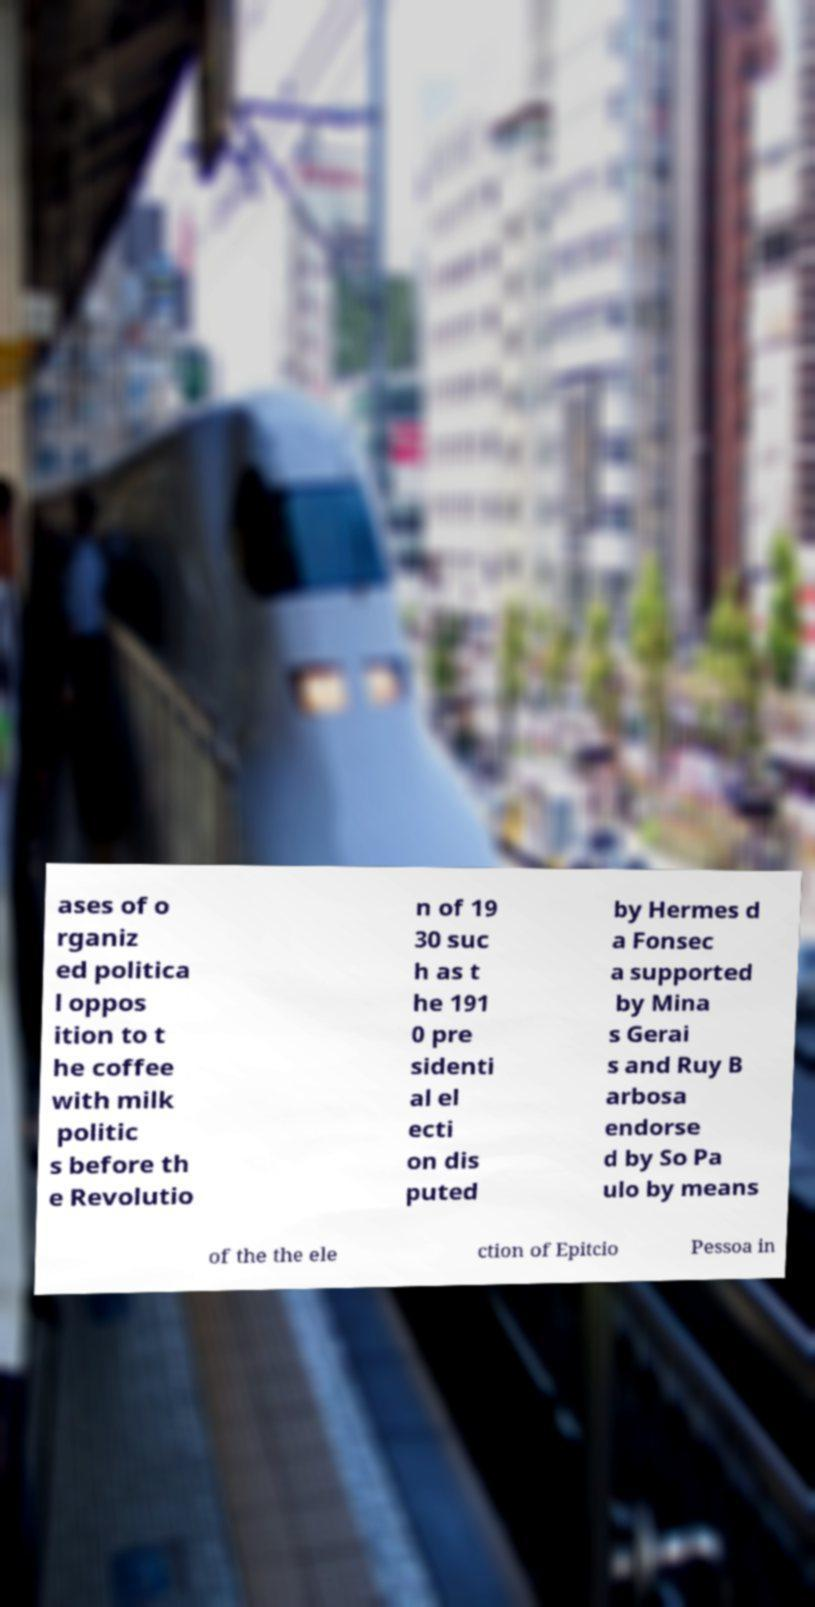What messages or text are displayed in this image? I need them in a readable, typed format. ases of o rganiz ed politica l oppos ition to t he coffee with milk politic s before th e Revolutio n of 19 30 suc h as t he 191 0 pre sidenti al el ecti on dis puted by Hermes d a Fonsec a supported by Mina s Gerai s and Ruy B arbosa endorse d by So Pa ulo by means of the the ele ction of Epitcio Pessoa in 